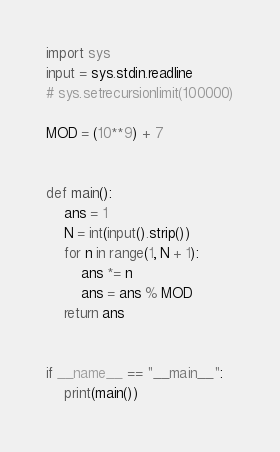Convert code to text. <code><loc_0><loc_0><loc_500><loc_500><_Python_>import sys
input = sys.stdin.readline
# sys.setrecursionlimit(100000)

MOD = (10**9) + 7


def main():
    ans = 1
    N = int(input().strip())
    for n in range(1, N + 1):
        ans *= n
        ans = ans % MOD
    return ans


if __name__ == "__main__":
    print(main())</code> 